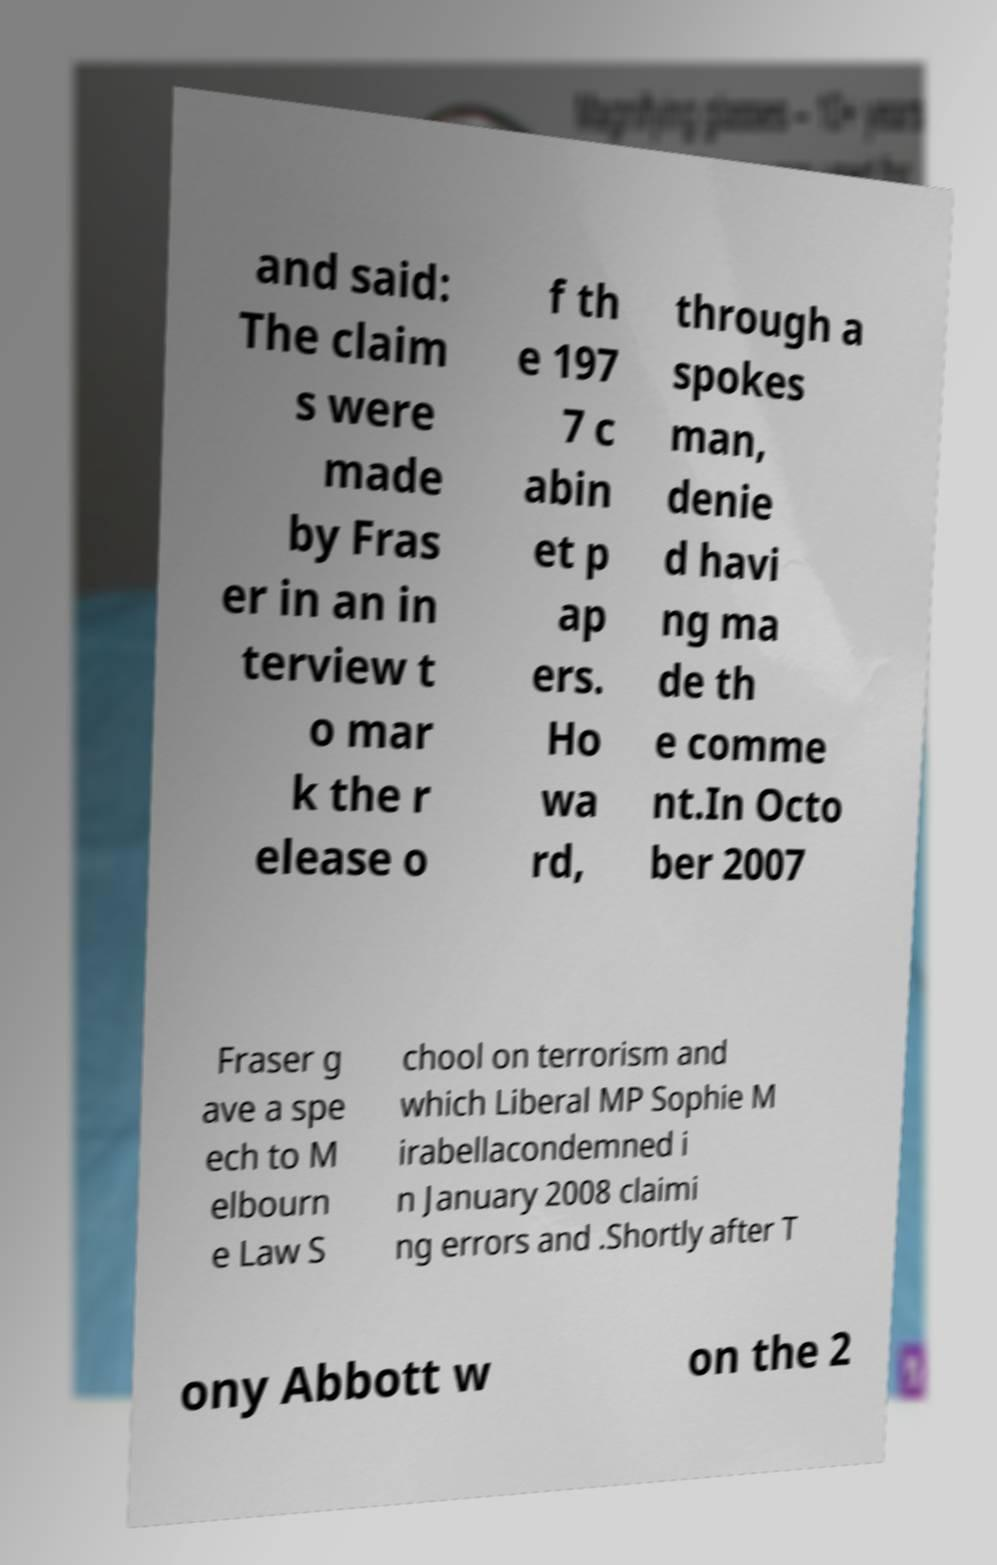Please read and relay the text visible in this image. What does it say? and said: The claim s were made by Fras er in an in terview t o mar k the r elease o f th e 197 7 c abin et p ap ers. Ho wa rd, through a spokes man, denie d havi ng ma de th e comme nt.In Octo ber 2007 Fraser g ave a spe ech to M elbourn e Law S chool on terrorism and which Liberal MP Sophie M irabellacondemned i n January 2008 claimi ng errors and .Shortly after T ony Abbott w on the 2 